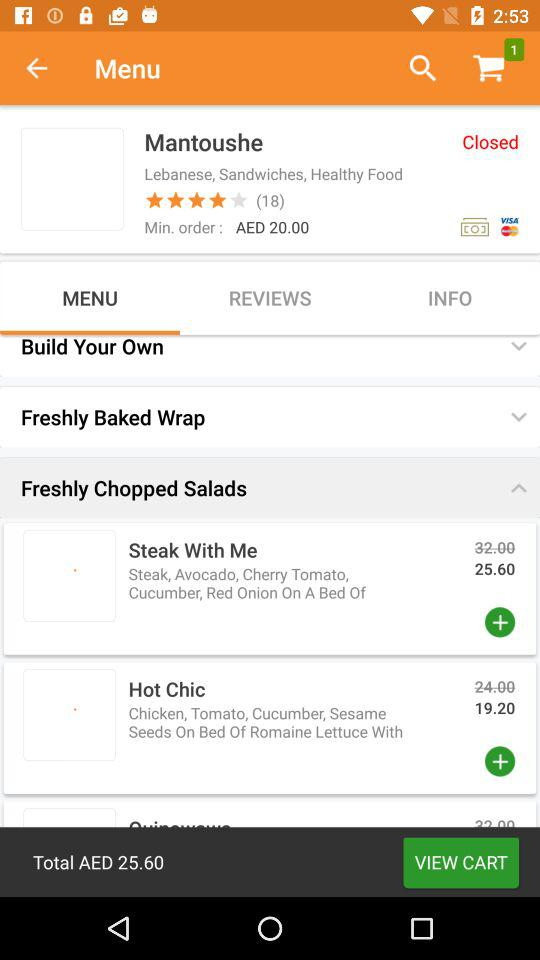What is the count of items in the cart? The count of items is 1. 